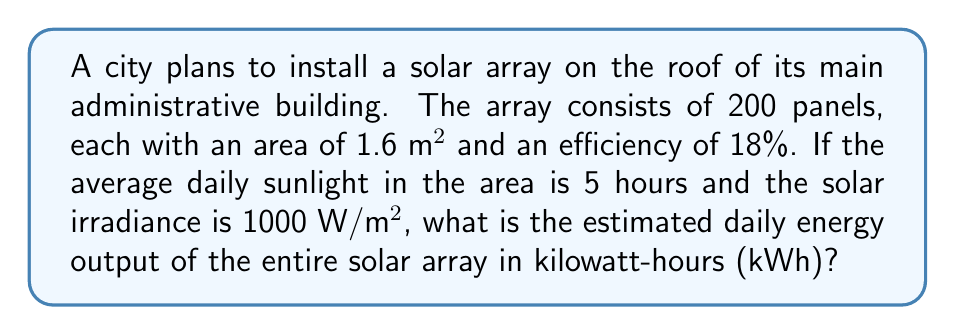Provide a solution to this math problem. Let's break this down step-by-step:

1) First, we need to calculate the total area of the solar array:
   $$ \text{Total Area} = \text{Number of Panels} \times \text{Area per Panel} $$
   $$ \text{Total Area} = 200 \times 1.6 \text{ m}^2 = 320 \text{ m}^2 $$

2) Now, we calculate the power output of the array:
   $$ \text{Power} = \text{Solar Irradiance} \times \text{Total Area} \times \text{Efficiency} $$
   $$ \text{Power} = 1000 \text{ W/m}^2 \times 320 \text{ m}^2 \times 0.18 = 57,600 \text{ W} = 57.6 \text{ kW} $$

3) To get the energy output, we multiply the power by the number of sunlight hours:
   $$ \text{Energy} = \text{Power} \times \text{Sunlight Hours} $$
   $$ \text{Energy} = 57.6 \text{ kW} \times 5 \text{ hours} = 288 \text{ kWh} $$

Therefore, the estimated daily energy output of the solar array is 288 kWh.
Answer: 288 kWh 